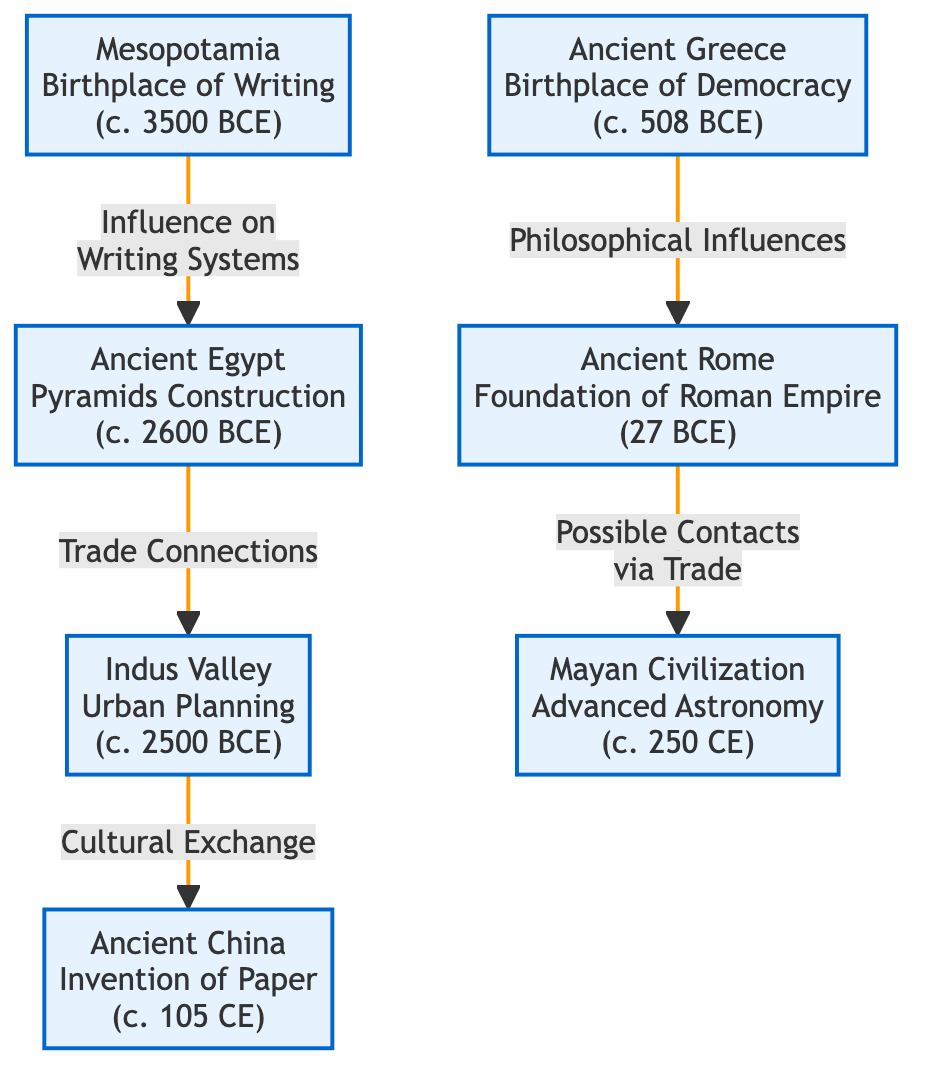What is the earliest civilization shown in the diagram? The diagram lists various civilizations with specific dates. Mesopotamia is noted to have existed around 3500 BCE, which is earlier than all other civilizations listed.
Answer: Mesopotamia What major contribution is associated with Ancient Egypt? The diagram indicates that Ancient Egypt is known for its Pyramids Construction around 2600 BCE. This is a significant contribution that highlights its architectural achievements.
Answer: Pyramids Construction How many civilizations are highlighted in the diagram? Counting the nodes in the diagram, there are seven distinct civilizations listed, each with their key event or contribution.
Answer: Seven What is the relationship between Mesopotamia and Ancient Egypt? The flow from Mesopotamia to Ancient Egypt indicates an influence on writing systems, showing a direct connection between the two civilizations in terms of cultural impact.
Answer: Influence on Writing Systems Which civilization is known for the invention of paper? The diagram specifies that Ancient China, dated around 105 CE, is recognized for the invention of paper. This innovation is essential in history, marking a significant advancement in communication.
Answer: Ancient China What event marks the foundation of the Roman Empire? The diagram indicates that the foundation of the Roman Empire occurred in 27 BCE, which is associated with ancient Roman history and its emergence as a powerful civilization.
Answer: Foundation of Roman Empire What semblance exists between Ancient Greece and Ancient Rome? The diagram denotes a connection where Ancient Greece provides philosophical influences to Ancient Rome, illustrating the flow of ideas between these two great civilizations.
Answer: Philosophical Influences Identify the civilization noted for advanced astronomy. The diagram clearly states that the Mayan Civilization, around 250 CE, is recognized for its advanced astronomical knowledge and contributions.
Answer: Mayan Civilization What type of cultural exchange is indicated between Indus Valley and Ancient China? The diagram details a cultural exchange between Indus Valley and Ancient China, suggesting significant interactions and sharing of ideas or practices between these regions.
Answer: Cultural Exchange 